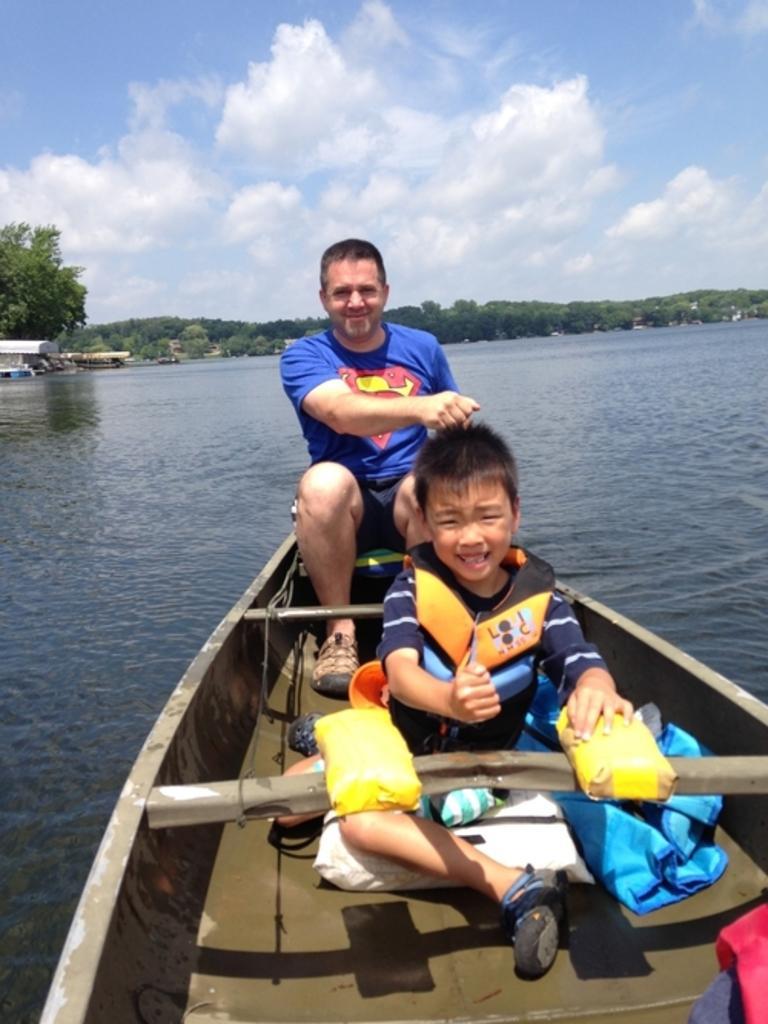In one or two sentences, can you explain what this image depicts? In the image we can see a man and a child wearing clothes, shoes and the child is wearing a life jacket, they are sitting in the boat. Here we can see water, trees and the cloudy sky. 